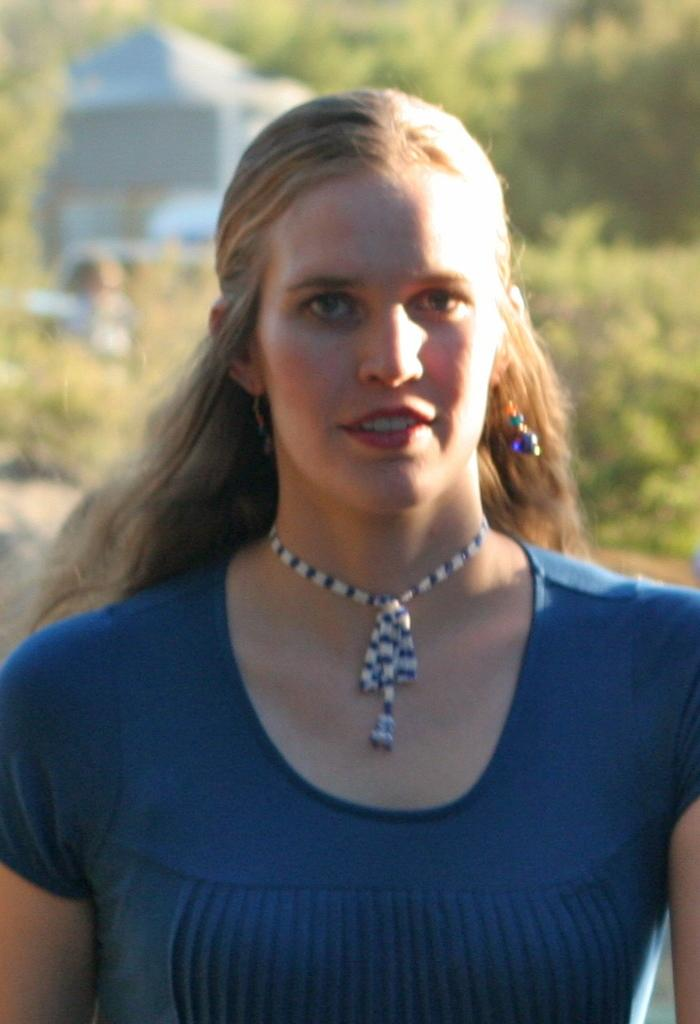Who is in the picture? There is a woman in the picture. What is the woman wearing on her upper body? The woman is wearing a blue shirt. What accessories is the woman wearing? The woman is wearing a necklace and earrings. What can be seen in the background of the picture? There are plants and trees in the background of the picture. How is the background of the picture depicted? The background is blurred. Can you tell me how many jellyfish are swimming in the background of the image? There are no jellyfish present in the image; the background features plants and trees. What type of current is affecting the woman's hair in the image? There is no indication of a current affecting the woman's hair in the image, as it appears to be still. 